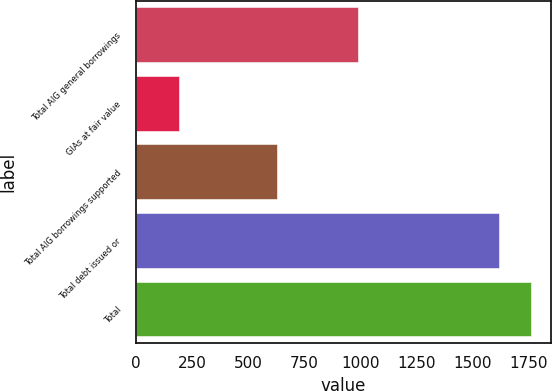Convert chart to OTSL. <chart><loc_0><loc_0><loc_500><loc_500><bar_chart><fcel>Total AIG general borrowings<fcel>GIAs at fair value<fcel>Total AIG borrowings supported<fcel>Total debt issued or<fcel>Total<nl><fcel>992<fcel>190<fcel>627<fcel>1619<fcel>1761.9<nl></chart> 